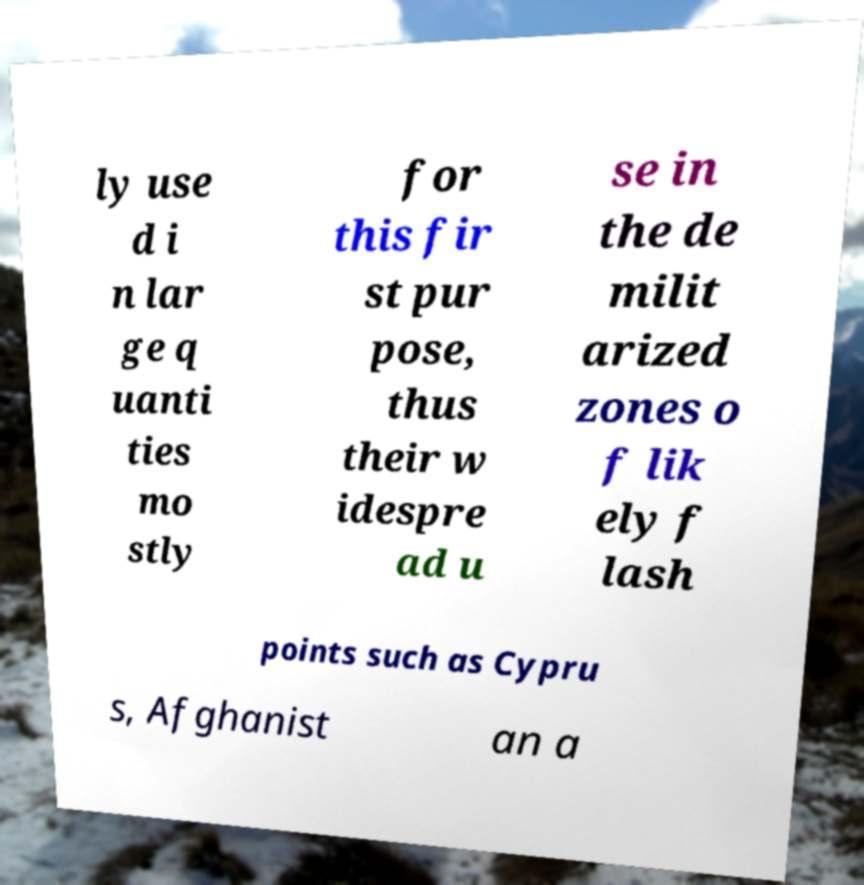For documentation purposes, I need the text within this image transcribed. Could you provide that? ly use d i n lar ge q uanti ties mo stly for this fir st pur pose, thus their w idespre ad u se in the de milit arized zones o f lik ely f lash points such as Cypru s, Afghanist an a 